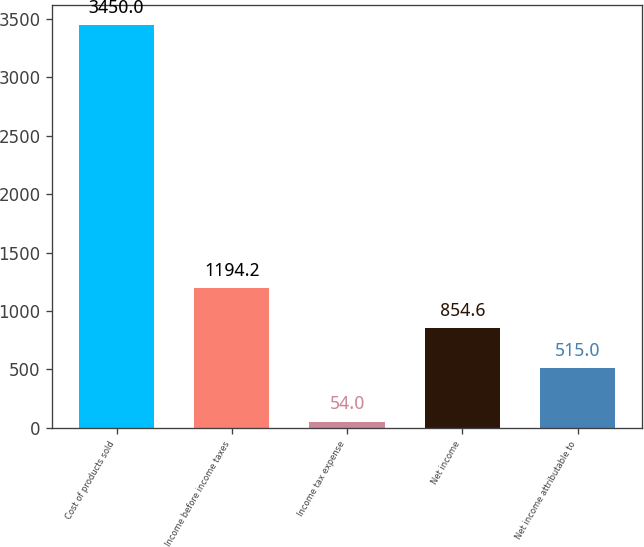Convert chart to OTSL. <chart><loc_0><loc_0><loc_500><loc_500><bar_chart><fcel>Cost of products sold<fcel>Income before income taxes<fcel>Income tax expense<fcel>Net income<fcel>Net income attributable to<nl><fcel>3450<fcel>1194.2<fcel>54<fcel>854.6<fcel>515<nl></chart> 